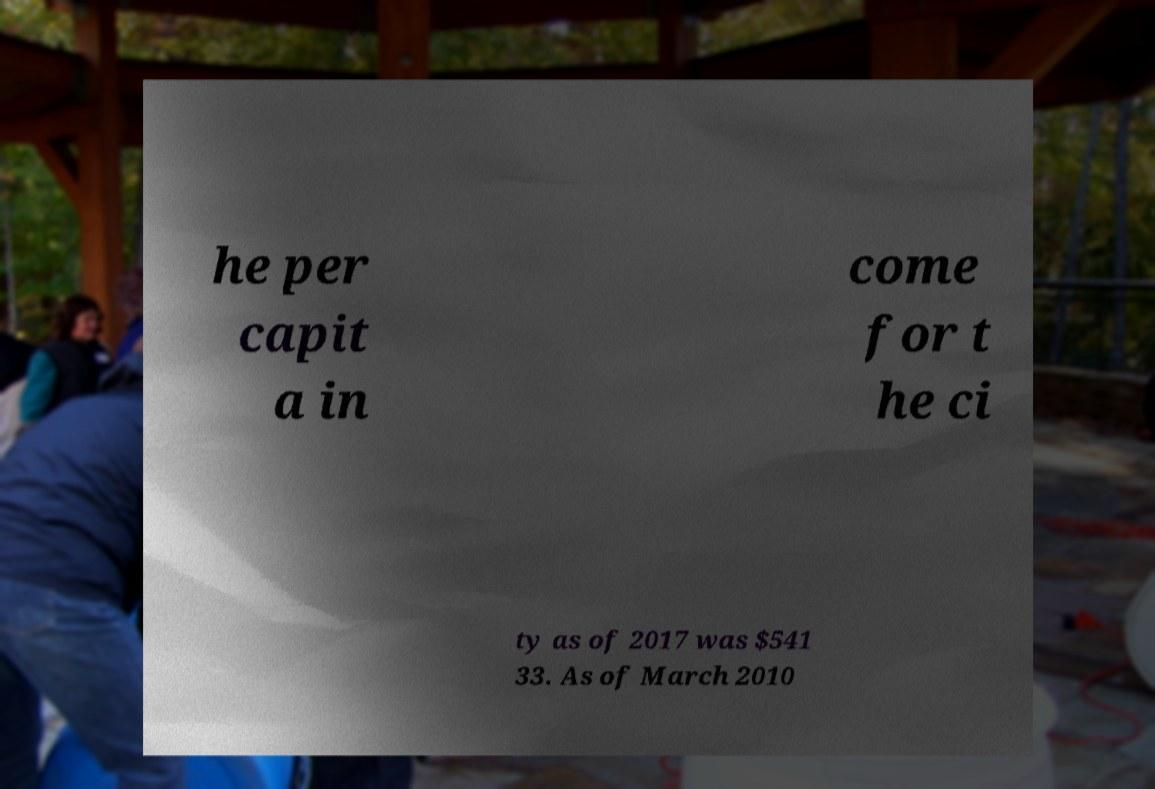There's text embedded in this image that I need extracted. Can you transcribe it verbatim? he per capit a in come for t he ci ty as of 2017 was $541 33. As of March 2010 